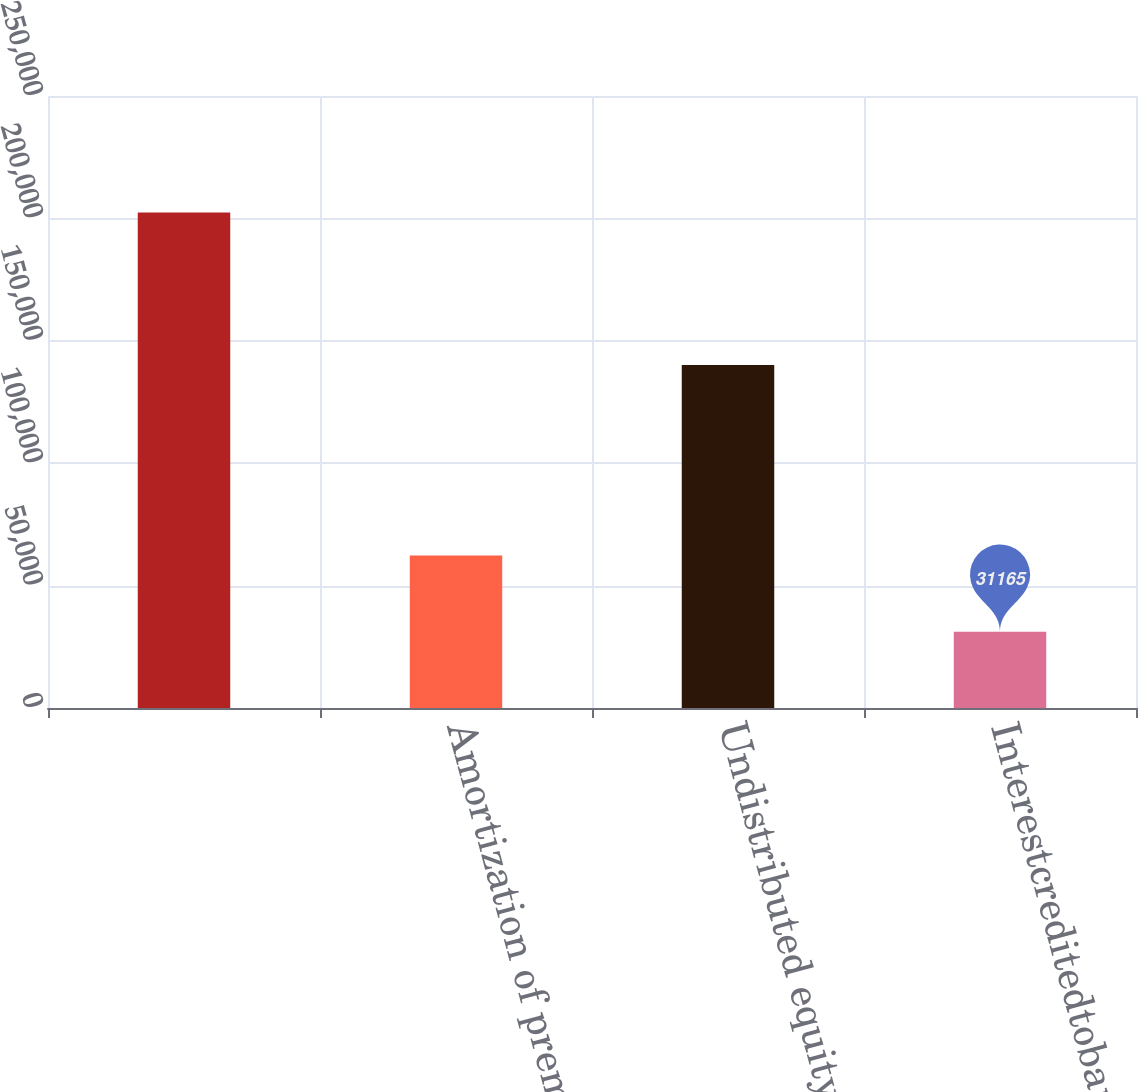Convert chart to OTSL. <chart><loc_0><loc_0><loc_500><loc_500><bar_chart><ecel><fcel>Amortization of premiums and<fcel>Undistributed equity earnings<fcel>Interestcreditedtobankdeposits<nl><fcel>202413<fcel>62301<fcel>140141<fcel>31165<nl></chart> 